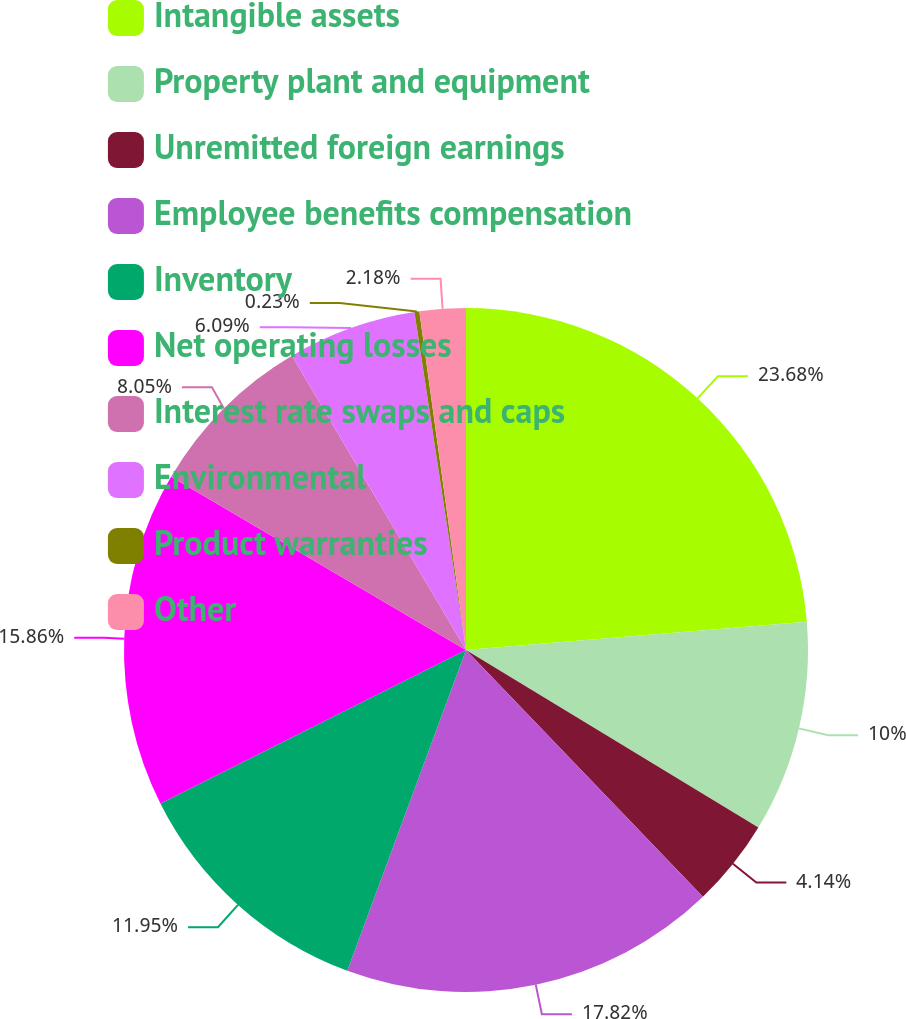<chart> <loc_0><loc_0><loc_500><loc_500><pie_chart><fcel>Intangible assets<fcel>Property plant and equipment<fcel>Unremitted foreign earnings<fcel>Employee benefits compensation<fcel>Inventory<fcel>Net operating losses<fcel>Interest rate swaps and caps<fcel>Environmental<fcel>Product warranties<fcel>Other<nl><fcel>23.68%<fcel>10.0%<fcel>4.14%<fcel>17.82%<fcel>11.95%<fcel>15.86%<fcel>8.05%<fcel>6.09%<fcel>0.23%<fcel>2.18%<nl></chart> 